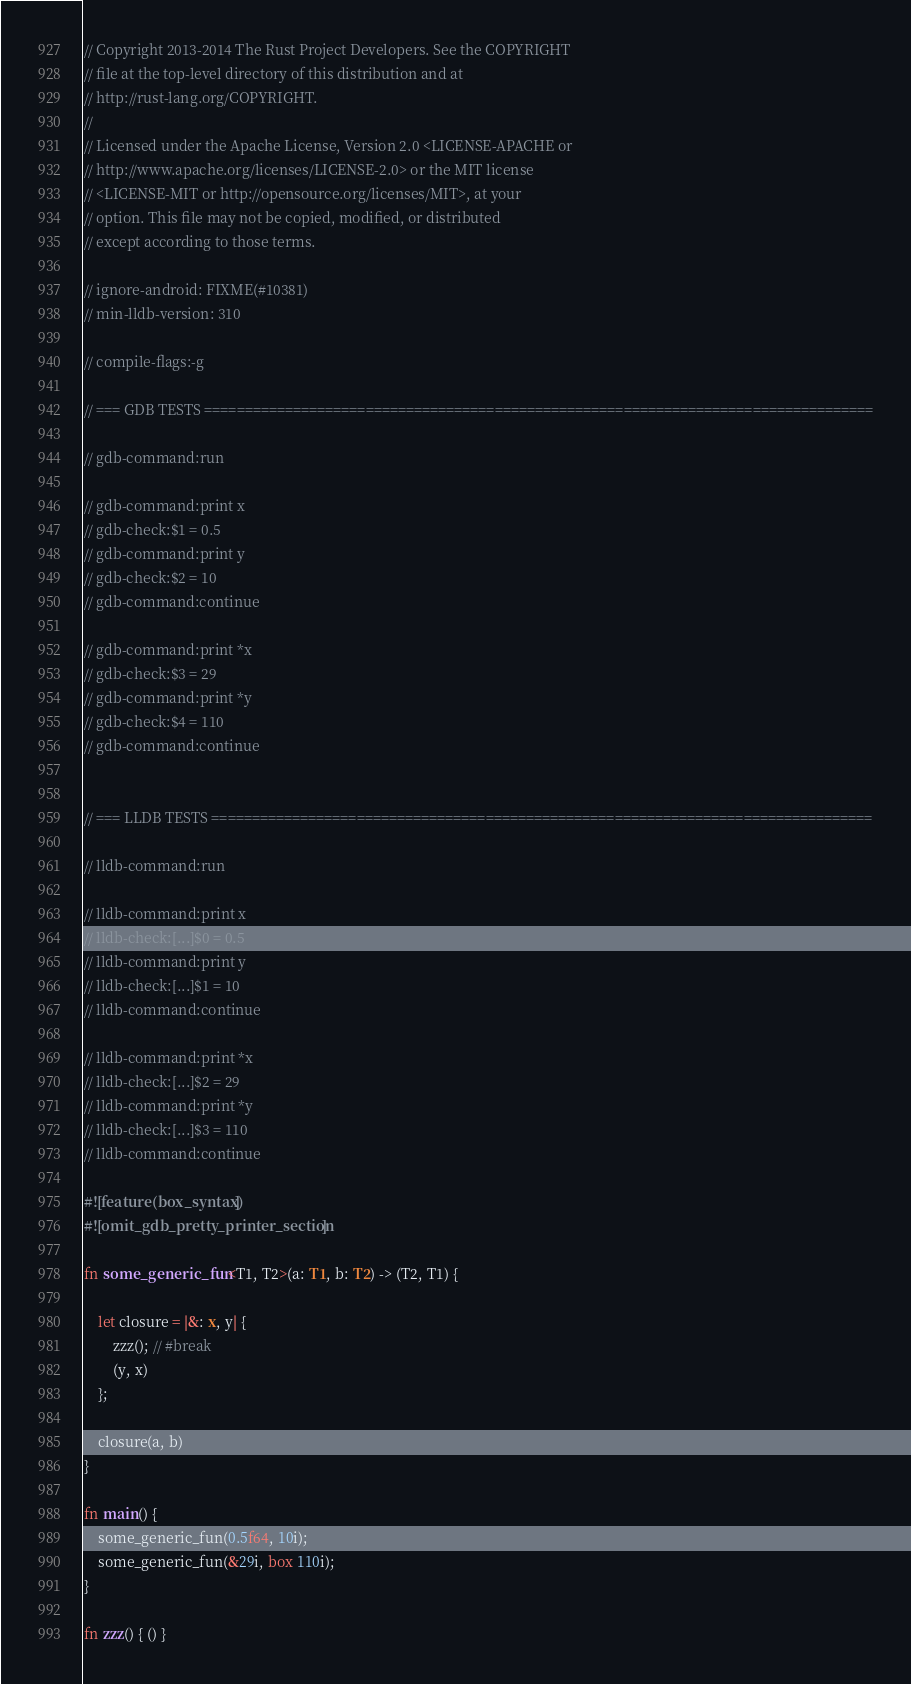<code> <loc_0><loc_0><loc_500><loc_500><_Rust_>// Copyright 2013-2014 The Rust Project Developers. See the COPYRIGHT
// file at the top-level directory of this distribution and at
// http://rust-lang.org/COPYRIGHT.
//
// Licensed under the Apache License, Version 2.0 <LICENSE-APACHE or
// http://www.apache.org/licenses/LICENSE-2.0> or the MIT license
// <LICENSE-MIT or http://opensource.org/licenses/MIT>, at your
// option. This file may not be copied, modified, or distributed
// except according to those terms.

// ignore-android: FIXME(#10381)
// min-lldb-version: 310

// compile-flags:-g

// === GDB TESTS ===================================================================================

// gdb-command:run

// gdb-command:print x
// gdb-check:$1 = 0.5
// gdb-command:print y
// gdb-check:$2 = 10
// gdb-command:continue

// gdb-command:print *x
// gdb-check:$3 = 29
// gdb-command:print *y
// gdb-check:$4 = 110
// gdb-command:continue


// === LLDB TESTS ==================================================================================

// lldb-command:run

// lldb-command:print x
// lldb-check:[...]$0 = 0.5
// lldb-command:print y
// lldb-check:[...]$1 = 10
// lldb-command:continue

// lldb-command:print *x
// lldb-check:[...]$2 = 29
// lldb-command:print *y
// lldb-check:[...]$3 = 110
// lldb-command:continue

#![feature(box_syntax)]
#![omit_gdb_pretty_printer_section]

fn some_generic_fun<T1, T2>(a: T1, b: T2) -> (T2, T1) {

    let closure = |&: x, y| {
        zzz(); // #break
        (y, x)
    };

    closure(a, b)
}

fn main() {
    some_generic_fun(0.5f64, 10i);
    some_generic_fun(&29i, box 110i);
}

fn zzz() { () }
</code> 